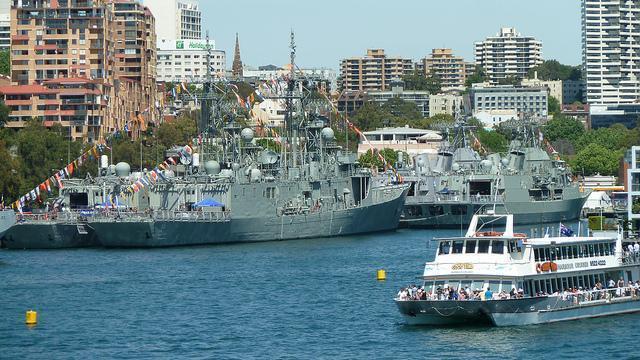How many boats are there?
Give a very brief answer. 3. 